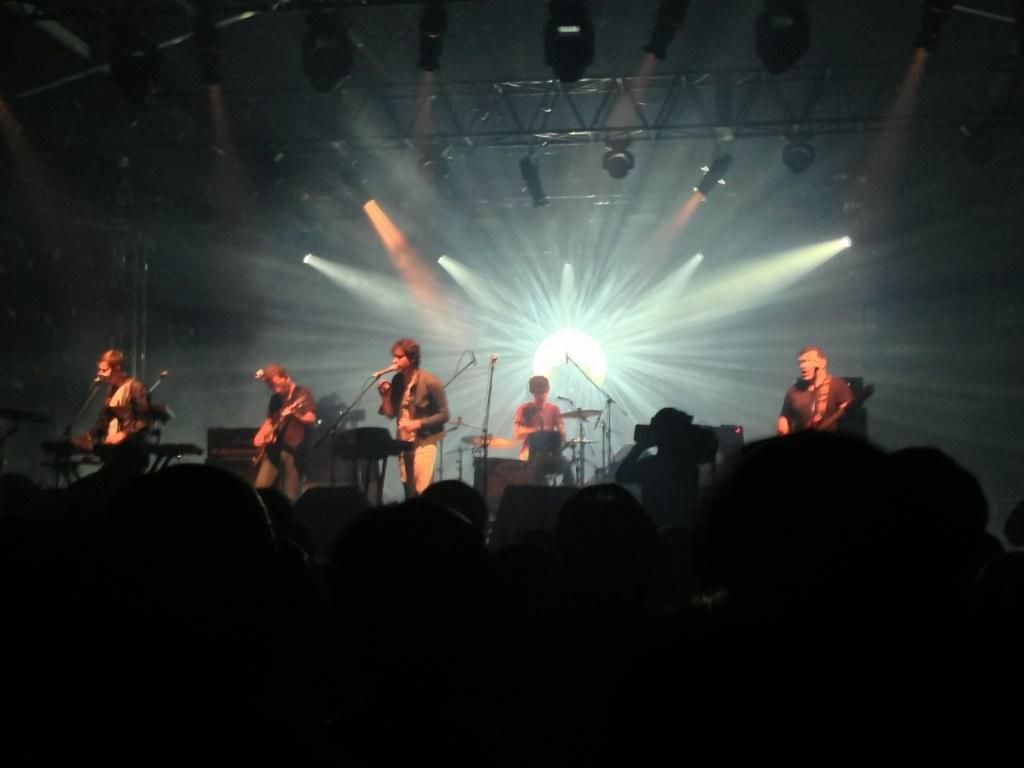What is happening in the center of the image? There are people performing a concert in the center of the image. Can you describe the people at the bottom of the image? There are people at the bottom of the image, but their actions or roles are not specified. What can be seen in the background of the image? There are lights visible in the background of the image. How does the stone contribute to the performance in the image? There is no stone present in the image, so it cannot contribute to the performance. 